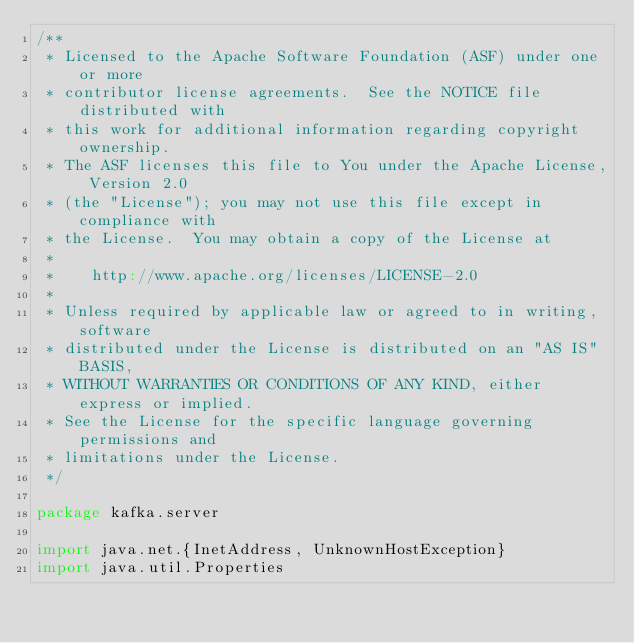<code> <loc_0><loc_0><loc_500><loc_500><_Scala_>/**
 * Licensed to the Apache Software Foundation (ASF) under one or more
 * contributor license agreements.  See the NOTICE file distributed with
 * this work for additional information regarding copyright ownership.
 * The ASF licenses this file to You under the Apache License, Version 2.0
 * (the "License"); you may not use this file except in compliance with
 * the License.  You may obtain a copy of the License at
 *
 *    http://www.apache.org/licenses/LICENSE-2.0
 *
 * Unless required by applicable law or agreed to in writing, software
 * distributed under the License is distributed on an "AS IS" BASIS,
 * WITHOUT WARRANTIES OR CONDITIONS OF ANY KIND, either express or implied.
 * See the License for the specific language governing permissions and
 * limitations under the License.
 */

package kafka.server

import java.net.{InetAddress, UnknownHostException}
import java.util.Properties</code> 